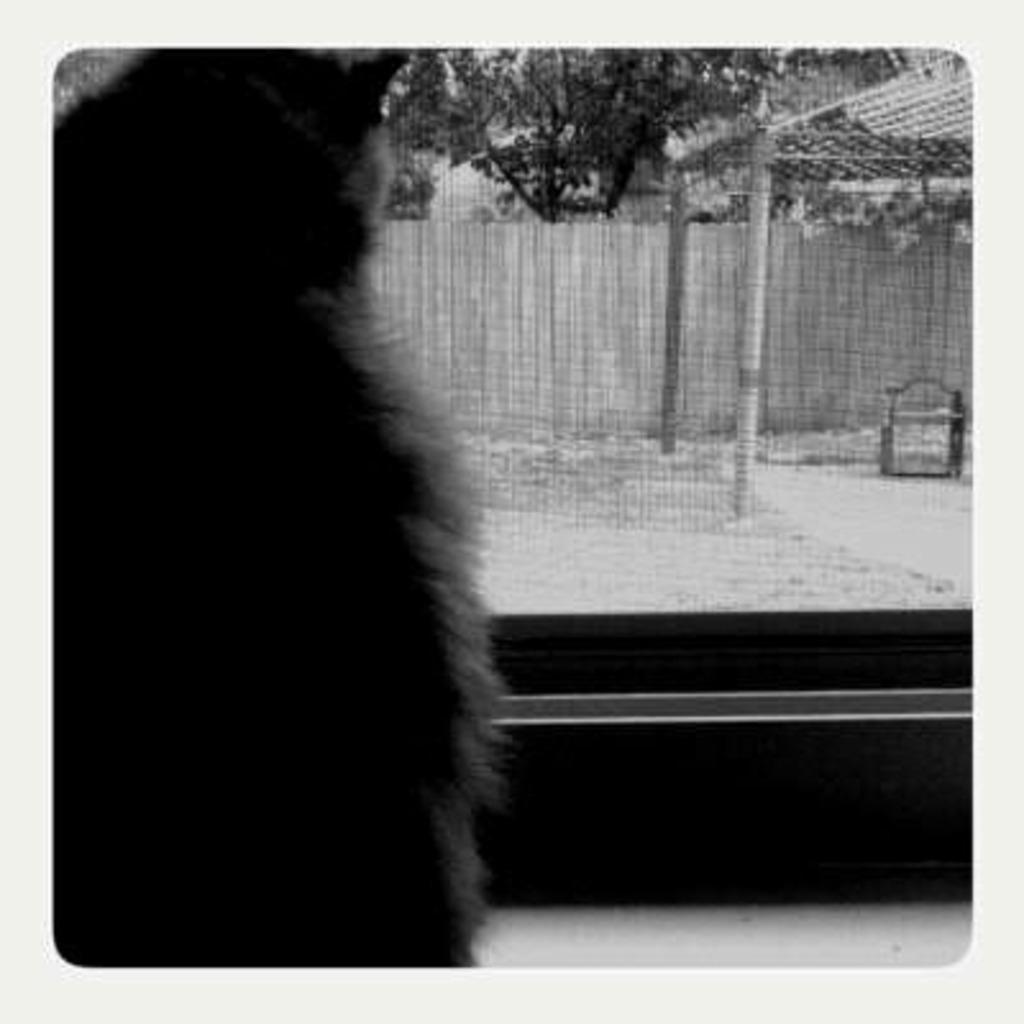Can you describe this image briefly? In this image I can see an animal and in background I can see a wall and a tree. 